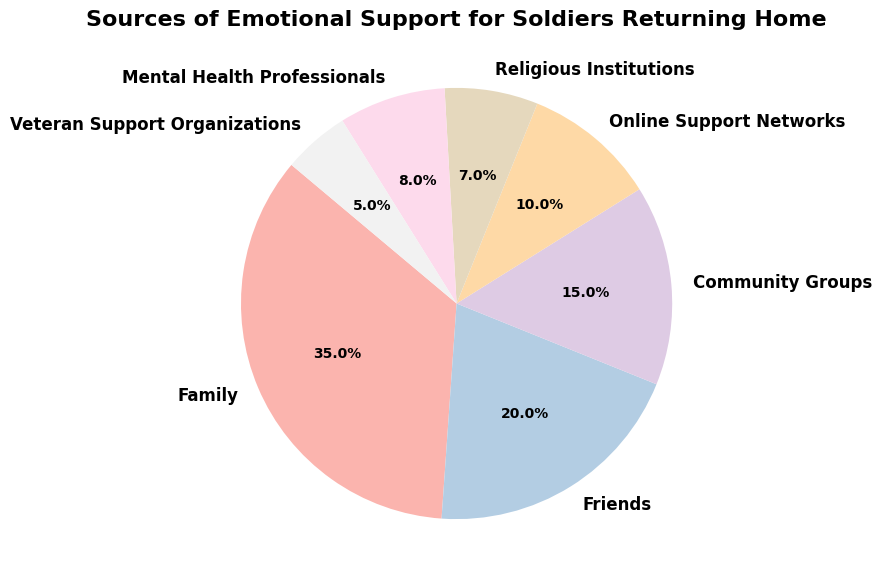What's the largest source of emotional support for soldiers returning home? The largest percentage slice in the pie chart represents the largest source of support. The category with the largest slice is "Family" with 35%.
Answer: Family Which source of emotional support is the least common? The smallest percentage slice in the pie chart represents the least common source of support. The category with the smallest slice is "Veteran Support Organizations" with 5%.
Answer: Veteran Support Organizations What is the combined percentage of support provided by friends and community groups? To find the combined percentage, sum up the individual percentages for Friends (20%) and Community Groups (15%). So, 20% + 15% = 35%.
Answer: 35% Is the percentage of support from Mental Health Professionals greater than that from Online Support Networks? Compare the percentages of these two categories. Mental Health Professionals provide 8%, while Online Support Networks provide 10%. Since 8% is less than 10%, the answer is no.
Answer: No How does the support from Religious Institutions compare to that from Veteran Support Organizations? Compare the percentages. Religious Institutions provide 7%, whereas Veteran Support Organizations provide 5%. Since 7% is greater than 5%, Religious Institutions offer more support.
Answer: Religious Institutions provide more support What's the total percentage of support coming from formal organizations (Community Groups, Religious Institutions, Mental Health Professionals, and Veteran Support Organizations)? Sum up the percentages of these categories: Community Groups (15%), Religious Institutions (7%), Mental Health Professionals (8%), and Veteran Support Organizations (5%). So, 15% + 7% + 8% + 5% = 35%.
Answer: 35% What portion of the pie chart does Online Support Networks occupy, visually? Online Support Networks occupy 10% of the pie chart. Visually, this is a smaller slice compared to other categories like Family and Friends.
Answer: 10% Looking at the colors in the pie chart, which category has the darkest shade? The pie chart uses gradients of the same color scheme (Pastel1), and generally, the largest and most significant category, "Family" with 35%, is represented using the darkest shade.
Answer: Family What's the difference in the percentage of support provided by Family and Friends? Subtract the percentage of Friends (20%) from that of Family (35%). So, 35% - 20% = 15%.
Answer: 15% 